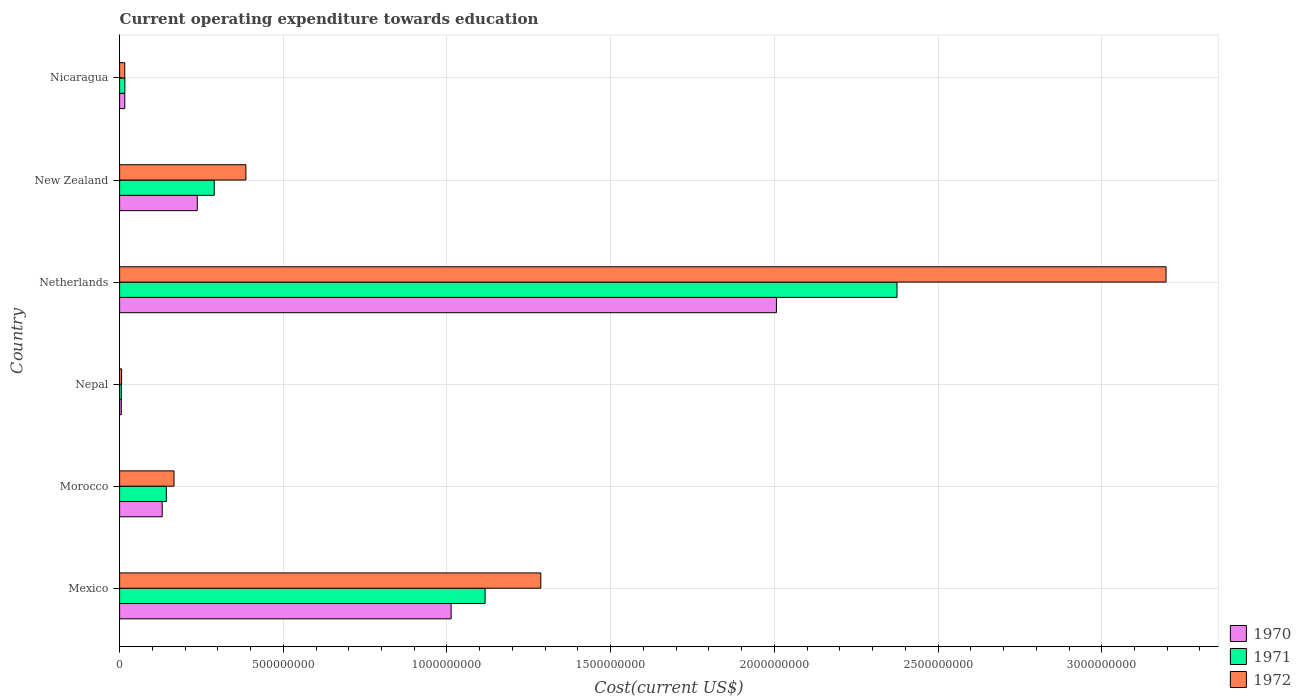How many different coloured bars are there?
Make the answer very short. 3. How many groups of bars are there?
Give a very brief answer. 6. Are the number of bars on each tick of the Y-axis equal?
Offer a terse response. Yes. How many bars are there on the 5th tick from the bottom?
Offer a terse response. 3. What is the expenditure towards education in 1970 in Nicaragua?
Your answer should be compact. 1.58e+07. Across all countries, what is the maximum expenditure towards education in 1972?
Ensure brevity in your answer.  3.20e+09. Across all countries, what is the minimum expenditure towards education in 1971?
Ensure brevity in your answer.  5.30e+06. In which country was the expenditure towards education in 1971 minimum?
Your response must be concise. Nepal. What is the total expenditure towards education in 1970 in the graph?
Offer a terse response. 3.41e+09. What is the difference between the expenditure towards education in 1971 in Nepal and that in Nicaragua?
Offer a very short reply. -1.08e+07. What is the difference between the expenditure towards education in 1971 in Netherlands and the expenditure towards education in 1972 in Morocco?
Offer a very short reply. 2.21e+09. What is the average expenditure towards education in 1971 per country?
Give a very brief answer. 6.57e+08. What is the difference between the expenditure towards education in 1972 and expenditure towards education in 1970 in Netherlands?
Provide a short and direct response. 1.19e+09. In how many countries, is the expenditure towards education in 1972 greater than 3000000000 US$?
Make the answer very short. 1. What is the ratio of the expenditure towards education in 1972 in Mexico to that in New Zealand?
Keep it short and to the point. 3.34. Is the expenditure towards education in 1972 in Morocco less than that in New Zealand?
Your answer should be very brief. Yes. What is the difference between the highest and the second highest expenditure towards education in 1970?
Offer a very short reply. 9.94e+08. What is the difference between the highest and the lowest expenditure towards education in 1972?
Your answer should be compact. 3.19e+09. What does the 3rd bar from the top in Netherlands represents?
Give a very brief answer. 1970. What does the 1st bar from the bottom in Nicaragua represents?
Your answer should be compact. 1970. How many countries are there in the graph?
Give a very brief answer. 6. Does the graph contain grids?
Give a very brief answer. Yes. How many legend labels are there?
Keep it short and to the point. 3. How are the legend labels stacked?
Provide a short and direct response. Vertical. What is the title of the graph?
Provide a short and direct response. Current operating expenditure towards education. What is the label or title of the X-axis?
Your answer should be compact. Cost(current US$). What is the Cost(current US$) of 1970 in Mexico?
Offer a terse response. 1.01e+09. What is the Cost(current US$) of 1971 in Mexico?
Offer a very short reply. 1.12e+09. What is the Cost(current US$) in 1972 in Mexico?
Ensure brevity in your answer.  1.29e+09. What is the Cost(current US$) in 1970 in Morocco?
Ensure brevity in your answer.  1.30e+08. What is the Cost(current US$) of 1971 in Morocco?
Make the answer very short. 1.43e+08. What is the Cost(current US$) of 1972 in Morocco?
Make the answer very short. 1.66e+08. What is the Cost(current US$) in 1970 in Nepal?
Offer a terse response. 5.20e+06. What is the Cost(current US$) of 1971 in Nepal?
Give a very brief answer. 5.30e+06. What is the Cost(current US$) in 1972 in Nepal?
Keep it short and to the point. 6.14e+06. What is the Cost(current US$) in 1970 in Netherlands?
Keep it short and to the point. 2.01e+09. What is the Cost(current US$) in 1971 in Netherlands?
Keep it short and to the point. 2.37e+09. What is the Cost(current US$) of 1972 in Netherlands?
Offer a terse response. 3.20e+09. What is the Cost(current US$) in 1970 in New Zealand?
Offer a very short reply. 2.37e+08. What is the Cost(current US$) of 1971 in New Zealand?
Provide a short and direct response. 2.89e+08. What is the Cost(current US$) of 1972 in New Zealand?
Offer a terse response. 3.86e+08. What is the Cost(current US$) of 1970 in Nicaragua?
Keep it short and to the point. 1.58e+07. What is the Cost(current US$) of 1971 in Nicaragua?
Provide a succinct answer. 1.61e+07. What is the Cost(current US$) in 1972 in Nicaragua?
Your answer should be very brief. 1.57e+07. Across all countries, what is the maximum Cost(current US$) of 1970?
Ensure brevity in your answer.  2.01e+09. Across all countries, what is the maximum Cost(current US$) of 1971?
Provide a succinct answer. 2.37e+09. Across all countries, what is the maximum Cost(current US$) in 1972?
Your answer should be very brief. 3.20e+09. Across all countries, what is the minimum Cost(current US$) of 1970?
Your answer should be compact. 5.20e+06. Across all countries, what is the minimum Cost(current US$) in 1971?
Offer a terse response. 5.30e+06. Across all countries, what is the minimum Cost(current US$) of 1972?
Your answer should be compact. 6.14e+06. What is the total Cost(current US$) of 1970 in the graph?
Give a very brief answer. 3.41e+09. What is the total Cost(current US$) in 1971 in the graph?
Give a very brief answer. 3.94e+09. What is the total Cost(current US$) in 1972 in the graph?
Provide a short and direct response. 5.06e+09. What is the difference between the Cost(current US$) of 1970 in Mexico and that in Morocco?
Your answer should be very brief. 8.82e+08. What is the difference between the Cost(current US$) in 1971 in Mexico and that in Morocco?
Provide a succinct answer. 9.74e+08. What is the difference between the Cost(current US$) of 1972 in Mexico and that in Morocco?
Your response must be concise. 1.12e+09. What is the difference between the Cost(current US$) of 1970 in Mexico and that in Nepal?
Ensure brevity in your answer.  1.01e+09. What is the difference between the Cost(current US$) in 1971 in Mexico and that in Nepal?
Offer a very short reply. 1.11e+09. What is the difference between the Cost(current US$) in 1972 in Mexico and that in Nepal?
Offer a terse response. 1.28e+09. What is the difference between the Cost(current US$) of 1970 in Mexico and that in Netherlands?
Give a very brief answer. -9.94e+08. What is the difference between the Cost(current US$) of 1971 in Mexico and that in Netherlands?
Your response must be concise. -1.26e+09. What is the difference between the Cost(current US$) in 1972 in Mexico and that in Netherlands?
Offer a terse response. -1.91e+09. What is the difference between the Cost(current US$) in 1970 in Mexico and that in New Zealand?
Offer a very short reply. 7.75e+08. What is the difference between the Cost(current US$) of 1971 in Mexico and that in New Zealand?
Offer a very short reply. 8.27e+08. What is the difference between the Cost(current US$) in 1972 in Mexico and that in New Zealand?
Your answer should be very brief. 9.01e+08. What is the difference between the Cost(current US$) of 1970 in Mexico and that in Nicaragua?
Ensure brevity in your answer.  9.97e+08. What is the difference between the Cost(current US$) of 1971 in Mexico and that in Nicaragua?
Your response must be concise. 1.10e+09. What is the difference between the Cost(current US$) of 1972 in Mexico and that in Nicaragua?
Offer a terse response. 1.27e+09. What is the difference between the Cost(current US$) of 1970 in Morocco and that in Nepal?
Offer a terse response. 1.25e+08. What is the difference between the Cost(current US$) of 1971 in Morocco and that in Nepal?
Your answer should be compact. 1.38e+08. What is the difference between the Cost(current US$) in 1972 in Morocco and that in Nepal?
Offer a terse response. 1.60e+08. What is the difference between the Cost(current US$) of 1970 in Morocco and that in Netherlands?
Your answer should be very brief. -1.88e+09. What is the difference between the Cost(current US$) in 1971 in Morocco and that in Netherlands?
Keep it short and to the point. -2.23e+09. What is the difference between the Cost(current US$) of 1972 in Morocco and that in Netherlands?
Your answer should be compact. -3.03e+09. What is the difference between the Cost(current US$) of 1970 in Morocco and that in New Zealand?
Your answer should be very brief. -1.07e+08. What is the difference between the Cost(current US$) of 1971 in Morocco and that in New Zealand?
Your answer should be compact. -1.46e+08. What is the difference between the Cost(current US$) in 1972 in Morocco and that in New Zealand?
Provide a short and direct response. -2.20e+08. What is the difference between the Cost(current US$) in 1970 in Morocco and that in Nicaragua?
Offer a very short reply. 1.14e+08. What is the difference between the Cost(current US$) of 1971 in Morocco and that in Nicaragua?
Provide a succinct answer. 1.27e+08. What is the difference between the Cost(current US$) of 1972 in Morocco and that in Nicaragua?
Your response must be concise. 1.50e+08. What is the difference between the Cost(current US$) in 1970 in Nepal and that in Netherlands?
Your answer should be compact. -2.00e+09. What is the difference between the Cost(current US$) of 1971 in Nepal and that in Netherlands?
Offer a terse response. -2.37e+09. What is the difference between the Cost(current US$) of 1972 in Nepal and that in Netherlands?
Keep it short and to the point. -3.19e+09. What is the difference between the Cost(current US$) in 1970 in Nepal and that in New Zealand?
Keep it short and to the point. -2.32e+08. What is the difference between the Cost(current US$) of 1971 in Nepal and that in New Zealand?
Offer a very short reply. -2.84e+08. What is the difference between the Cost(current US$) in 1972 in Nepal and that in New Zealand?
Your answer should be very brief. -3.80e+08. What is the difference between the Cost(current US$) of 1970 in Nepal and that in Nicaragua?
Keep it short and to the point. -1.06e+07. What is the difference between the Cost(current US$) in 1971 in Nepal and that in Nicaragua?
Offer a very short reply. -1.08e+07. What is the difference between the Cost(current US$) in 1972 in Nepal and that in Nicaragua?
Keep it short and to the point. -9.60e+06. What is the difference between the Cost(current US$) in 1970 in Netherlands and that in New Zealand?
Your answer should be very brief. 1.77e+09. What is the difference between the Cost(current US$) in 1971 in Netherlands and that in New Zealand?
Ensure brevity in your answer.  2.09e+09. What is the difference between the Cost(current US$) of 1972 in Netherlands and that in New Zealand?
Your answer should be very brief. 2.81e+09. What is the difference between the Cost(current US$) of 1970 in Netherlands and that in Nicaragua?
Provide a short and direct response. 1.99e+09. What is the difference between the Cost(current US$) of 1971 in Netherlands and that in Nicaragua?
Ensure brevity in your answer.  2.36e+09. What is the difference between the Cost(current US$) of 1972 in Netherlands and that in Nicaragua?
Offer a very short reply. 3.18e+09. What is the difference between the Cost(current US$) of 1970 in New Zealand and that in Nicaragua?
Your answer should be compact. 2.21e+08. What is the difference between the Cost(current US$) of 1971 in New Zealand and that in Nicaragua?
Your response must be concise. 2.73e+08. What is the difference between the Cost(current US$) in 1972 in New Zealand and that in Nicaragua?
Make the answer very short. 3.70e+08. What is the difference between the Cost(current US$) of 1970 in Mexico and the Cost(current US$) of 1971 in Morocco?
Your answer should be very brief. 8.70e+08. What is the difference between the Cost(current US$) of 1970 in Mexico and the Cost(current US$) of 1972 in Morocco?
Provide a succinct answer. 8.46e+08. What is the difference between the Cost(current US$) in 1971 in Mexico and the Cost(current US$) in 1972 in Morocco?
Provide a short and direct response. 9.50e+08. What is the difference between the Cost(current US$) in 1970 in Mexico and the Cost(current US$) in 1971 in Nepal?
Make the answer very short. 1.01e+09. What is the difference between the Cost(current US$) of 1970 in Mexico and the Cost(current US$) of 1972 in Nepal?
Give a very brief answer. 1.01e+09. What is the difference between the Cost(current US$) of 1971 in Mexico and the Cost(current US$) of 1972 in Nepal?
Your answer should be very brief. 1.11e+09. What is the difference between the Cost(current US$) in 1970 in Mexico and the Cost(current US$) in 1971 in Netherlands?
Make the answer very short. -1.36e+09. What is the difference between the Cost(current US$) of 1970 in Mexico and the Cost(current US$) of 1972 in Netherlands?
Ensure brevity in your answer.  -2.18e+09. What is the difference between the Cost(current US$) of 1971 in Mexico and the Cost(current US$) of 1972 in Netherlands?
Your answer should be compact. -2.08e+09. What is the difference between the Cost(current US$) of 1970 in Mexico and the Cost(current US$) of 1971 in New Zealand?
Your response must be concise. 7.24e+08. What is the difference between the Cost(current US$) of 1970 in Mexico and the Cost(current US$) of 1972 in New Zealand?
Provide a short and direct response. 6.27e+08. What is the difference between the Cost(current US$) in 1971 in Mexico and the Cost(current US$) in 1972 in New Zealand?
Ensure brevity in your answer.  7.31e+08. What is the difference between the Cost(current US$) in 1970 in Mexico and the Cost(current US$) in 1971 in Nicaragua?
Ensure brevity in your answer.  9.97e+08. What is the difference between the Cost(current US$) in 1970 in Mexico and the Cost(current US$) in 1972 in Nicaragua?
Your response must be concise. 9.97e+08. What is the difference between the Cost(current US$) of 1971 in Mexico and the Cost(current US$) of 1972 in Nicaragua?
Provide a short and direct response. 1.10e+09. What is the difference between the Cost(current US$) of 1970 in Morocco and the Cost(current US$) of 1971 in Nepal?
Your answer should be very brief. 1.25e+08. What is the difference between the Cost(current US$) in 1970 in Morocco and the Cost(current US$) in 1972 in Nepal?
Provide a short and direct response. 1.24e+08. What is the difference between the Cost(current US$) in 1971 in Morocco and the Cost(current US$) in 1972 in Nepal?
Your answer should be very brief. 1.37e+08. What is the difference between the Cost(current US$) of 1970 in Morocco and the Cost(current US$) of 1971 in Netherlands?
Your answer should be compact. -2.24e+09. What is the difference between the Cost(current US$) in 1970 in Morocco and the Cost(current US$) in 1972 in Netherlands?
Your answer should be very brief. -3.07e+09. What is the difference between the Cost(current US$) of 1971 in Morocco and the Cost(current US$) of 1972 in Netherlands?
Give a very brief answer. -3.05e+09. What is the difference between the Cost(current US$) of 1970 in Morocco and the Cost(current US$) of 1971 in New Zealand?
Offer a terse response. -1.59e+08. What is the difference between the Cost(current US$) of 1970 in Morocco and the Cost(current US$) of 1972 in New Zealand?
Provide a succinct answer. -2.56e+08. What is the difference between the Cost(current US$) of 1971 in Morocco and the Cost(current US$) of 1972 in New Zealand?
Your answer should be very brief. -2.43e+08. What is the difference between the Cost(current US$) in 1970 in Morocco and the Cost(current US$) in 1971 in Nicaragua?
Ensure brevity in your answer.  1.14e+08. What is the difference between the Cost(current US$) of 1970 in Morocco and the Cost(current US$) of 1972 in Nicaragua?
Make the answer very short. 1.14e+08. What is the difference between the Cost(current US$) of 1971 in Morocco and the Cost(current US$) of 1972 in Nicaragua?
Provide a short and direct response. 1.27e+08. What is the difference between the Cost(current US$) of 1970 in Nepal and the Cost(current US$) of 1971 in Netherlands?
Offer a terse response. -2.37e+09. What is the difference between the Cost(current US$) of 1970 in Nepal and the Cost(current US$) of 1972 in Netherlands?
Your response must be concise. -3.19e+09. What is the difference between the Cost(current US$) in 1971 in Nepal and the Cost(current US$) in 1972 in Netherlands?
Your answer should be compact. -3.19e+09. What is the difference between the Cost(current US$) in 1970 in Nepal and the Cost(current US$) in 1971 in New Zealand?
Your response must be concise. -2.84e+08. What is the difference between the Cost(current US$) in 1970 in Nepal and the Cost(current US$) in 1972 in New Zealand?
Your answer should be compact. -3.81e+08. What is the difference between the Cost(current US$) in 1971 in Nepal and the Cost(current US$) in 1972 in New Zealand?
Ensure brevity in your answer.  -3.80e+08. What is the difference between the Cost(current US$) in 1970 in Nepal and the Cost(current US$) in 1971 in Nicaragua?
Your response must be concise. -1.09e+07. What is the difference between the Cost(current US$) of 1970 in Nepal and the Cost(current US$) of 1972 in Nicaragua?
Your response must be concise. -1.05e+07. What is the difference between the Cost(current US$) of 1971 in Nepal and the Cost(current US$) of 1972 in Nicaragua?
Offer a very short reply. -1.04e+07. What is the difference between the Cost(current US$) in 1970 in Netherlands and the Cost(current US$) in 1971 in New Zealand?
Make the answer very short. 1.72e+09. What is the difference between the Cost(current US$) in 1970 in Netherlands and the Cost(current US$) in 1972 in New Zealand?
Provide a short and direct response. 1.62e+09. What is the difference between the Cost(current US$) of 1971 in Netherlands and the Cost(current US$) of 1972 in New Zealand?
Your answer should be compact. 1.99e+09. What is the difference between the Cost(current US$) in 1970 in Netherlands and the Cost(current US$) in 1971 in Nicaragua?
Your answer should be very brief. 1.99e+09. What is the difference between the Cost(current US$) of 1970 in Netherlands and the Cost(current US$) of 1972 in Nicaragua?
Offer a terse response. 1.99e+09. What is the difference between the Cost(current US$) in 1971 in Netherlands and the Cost(current US$) in 1972 in Nicaragua?
Keep it short and to the point. 2.36e+09. What is the difference between the Cost(current US$) in 1970 in New Zealand and the Cost(current US$) in 1971 in Nicaragua?
Ensure brevity in your answer.  2.21e+08. What is the difference between the Cost(current US$) in 1970 in New Zealand and the Cost(current US$) in 1972 in Nicaragua?
Make the answer very short. 2.22e+08. What is the difference between the Cost(current US$) in 1971 in New Zealand and the Cost(current US$) in 1972 in Nicaragua?
Your response must be concise. 2.73e+08. What is the average Cost(current US$) of 1970 per country?
Give a very brief answer. 5.68e+08. What is the average Cost(current US$) of 1971 per country?
Offer a terse response. 6.57e+08. What is the average Cost(current US$) of 1972 per country?
Provide a short and direct response. 8.43e+08. What is the difference between the Cost(current US$) of 1970 and Cost(current US$) of 1971 in Mexico?
Give a very brief answer. -1.04e+08. What is the difference between the Cost(current US$) of 1970 and Cost(current US$) of 1972 in Mexico?
Provide a succinct answer. -2.74e+08. What is the difference between the Cost(current US$) of 1971 and Cost(current US$) of 1972 in Mexico?
Your answer should be compact. -1.70e+08. What is the difference between the Cost(current US$) in 1970 and Cost(current US$) in 1971 in Morocco?
Keep it short and to the point. -1.27e+07. What is the difference between the Cost(current US$) in 1970 and Cost(current US$) in 1972 in Morocco?
Give a very brief answer. -3.61e+07. What is the difference between the Cost(current US$) of 1971 and Cost(current US$) of 1972 in Morocco?
Your answer should be compact. -2.34e+07. What is the difference between the Cost(current US$) of 1970 and Cost(current US$) of 1971 in Nepal?
Offer a terse response. -1.01e+05. What is the difference between the Cost(current US$) of 1970 and Cost(current US$) of 1972 in Nepal?
Provide a short and direct response. -9.49e+05. What is the difference between the Cost(current US$) of 1971 and Cost(current US$) of 1972 in Nepal?
Provide a short and direct response. -8.48e+05. What is the difference between the Cost(current US$) of 1970 and Cost(current US$) of 1971 in Netherlands?
Keep it short and to the point. -3.68e+08. What is the difference between the Cost(current US$) in 1970 and Cost(current US$) in 1972 in Netherlands?
Keep it short and to the point. -1.19e+09. What is the difference between the Cost(current US$) of 1971 and Cost(current US$) of 1972 in Netherlands?
Give a very brief answer. -8.22e+08. What is the difference between the Cost(current US$) of 1970 and Cost(current US$) of 1971 in New Zealand?
Provide a short and direct response. -5.18e+07. What is the difference between the Cost(current US$) of 1970 and Cost(current US$) of 1972 in New Zealand?
Provide a succinct answer. -1.49e+08. What is the difference between the Cost(current US$) in 1971 and Cost(current US$) in 1972 in New Zealand?
Make the answer very short. -9.67e+07. What is the difference between the Cost(current US$) in 1970 and Cost(current US$) in 1971 in Nicaragua?
Ensure brevity in your answer.  -3.03e+05. What is the difference between the Cost(current US$) of 1970 and Cost(current US$) of 1972 in Nicaragua?
Ensure brevity in your answer.  3.08e+04. What is the difference between the Cost(current US$) of 1971 and Cost(current US$) of 1972 in Nicaragua?
Keep it short and to the point. 3.34e+05. What is the ratio of the Cost(current US$) of 1970 in Mexico to that in Morocco?
Make the answer very short. 7.78. What is the ratio of the Cost(current US$) in 1971 in Mexico to that in Morocco?
Ensure brevity in your answer.  7.82. What is the ratio of the Cost(current US$) in 1972 in Mexico to that in Morocco?
Keep it short and to the point. 7.74. What is the ratio of the Cost(current US$) in 1970 in Mexico to that in Nepal?
Offer a very short reply. 194.9. What is the ratio of the Cost(current US$) in 1971 in Mexico to that in Nepal?
Provide a short and direct response. 210.78. What is the ratio of the Cost(current US$) in 1972 in Mexico to that in Nepal?
Provide a short and direct response. 209.39. What is the ratio of the Cost(current US$) of 1970 in Mexico to that in Netherlands?
Ensure brevity in your answer.  0.5. What is the ratio of the Cost(current US$) of 1971 in Mexico to that in Netherlands?
Offer a very short reply. 0.47. What is the ratio of the Cost(current US$) in 1972 in Mexico to that in Netherlands?
Your answer should be compact. 0.4. What is the ratio of the Cost(current US$) in 1970 in Mexico to that in New Zealand?
Your response must be concise. 4.27. What is the ratio of the Cost(current US$) of 1971 in Mexico to that in New Zealand?
Your answer should be compact. 3.86. What is the ratio of the Cost(current US$) of 1972 in Mexico to that in New Zealand?
Ensure brevity in your answer.  3.33. What is the ratio of the Cost(current US$) in 1970 in Mexico to that in Nicaragua?
Your answer should be very brief. 64.2. What is the ratio of the Cost(current US$) in 1971 in Mexico to that in Nicaragua?
Offer a terse response. 69.44. What is the ratio of the Cost(current US$) in 1972 in Mexico to that in Nicaragua?
Ensure brevity in your answer.  81.73. What is the ratio of the Cost(current US$) in 1970 in Morocco to that in Nepal?
Provide a short and direct response. 25.05. What is the ratio of the Cost(current US$) of 1971 in Morocco to that in Nepal?
Keep it short and to the point. 26.97. What is the ratio of the Cost(current US$) of 1972 in Morocco to that in Nepal?
Offer a very short reply. 27.05. What is the ratio of the Cost(current US$) of 1970 in Morocco to that in Netherlands?
Offer a terse response. 0.06. What is the ratio of the Cost(current US$) in 1971 in Morocco to that in Netherlands?
Your answer should be very brief. 0.06. What is the ratio of the Cost(current US$) in 1972 in Morocco to that in Netherlands?
Make the answer very short. 0.05. What is the ratio of the Cost(current US$) in 1970 in Morocco to that in New Zealand?
Offer a very short reply. 0.55. What is the ratio of the Cost(current US$) of 1971 in Morocco to that in New Zealand?
Your response must be concise. 0.49. What is the ratio of the Cost(current US$) of 1972 in Morocco to that in New Zealand?
Offer a terse response. 0.43. What is the ratio of the Cost(current US$) of 1970 in Morocco to that in Nicaragua?
Keep it short and to the point. 8.25. What is the ratio of the Cost(current US$) of 1971 in Morocco to that in Nicaragua?
Provide a short and direct response. 8.88. What is the ratio of the Cost(current US$) of 1972 in Morocco to that in Nicaragua?
Offer a very short reply. 10.56. What is the ratio of the Cost(current US$) of 1970 in Nepal to that in Netherlands?
Your response must be concise. 0. What is the ratio of the Cost(current US$) of 1971 in Nepal to that in Netherlands?
Provide a succinct answer. 0. What is the ratio of the Cost(current US$) of 1972 in Nepal to that in Netherlands?
Keep it short and to the point. 0. What is the ratio of the Cost(current US$) of 1970 in Nepal to that in New Zealand?
Give a very brief answer. 0.02. What is the ratio of the Cost(current US$) in 1971 in Nepal to that in New Zealand?
Give a very brief answer. 0.02. What is the ratio of the Cost(current US$) of 1972 in Nepal to that in New Zealand?
Your response must be concise. 0.02. What is the ratio of the Cost(current US$) of 1970 in Nepal to that in Nicaragua?
Offer a terse response. 0.33. What is the ratio of the Cost(current US$) in 1971 in Nepal to that in Nicaragua?
Your answer should be very brief. 0.33. What is the ratio of the Cost(current US$) in 1972 in Nepal to that in Nicaragua?
Your answer should be very brief. 0.39. What is the ratio of the Cost(current US$) in 1970 in Netherlands to that in New Zealand?
Your response must be concise. 8.46. What is the ratio of the Cost(current US$) of 1971 in Netherlands to that in New Zealand?
Offer a very short reply. 8.21. What is the ratio of the Cost(current US$) of 1972 in Netherlands to that in New Zealand?
Your answer should be very brief. 8.29. What is the ratio of the Cost(current US$) in 1970 in Netherlands to that in Nicaragua?
Make the answer very short. 127.19. What is the ratio of the Cost(current US$) in 1971 in Netherlands to that in Nicaragua?
Offer a terse response. 147.7. What is the ratio of the Cost(current US$) of 1972 in Netherlands to that in Nicaragua?
Keep it short and to the point. 203.04. What is the ratio of the Cost(current US$) in 1970 in New Zealand to that in Nicaragua?
Ensure brevity in your answer.  15.04. What is the ratio of the Cost(current US$) of 1971 in New Zealand to that in Nicaragua?
Your answer should be compact. 17.98. What is the ratio of the Cost(current US$) of 1972 in New Zealand to that in Nicaragua?
Make the answer very short. 24.51. What is the difference between the highest and the second highest Cost(current US$) of 1970?
Give a very brief answer. 9.94e+08. What is the difference between the highest and the second highest Cost(current US$) of 1971?
Offer a very short reply. 1.26e+09. What is the difference between the highest and the second highest Cost(current US$) in 1972?
Your response must be concise. 1.91e+09. What is the difference between the highest and the lowest Cost(current US$) of 1970?
Ensure brevity in your answer.  2.00e+09. What is the difference between the highest and the lowest Cost(current US$) of 1971?
Your answer should be compact. 2.37e+09. What is the difference between the highest and the lowest Cost(current US$) of 1972?
Your response must be concise. 3.19e+09. 